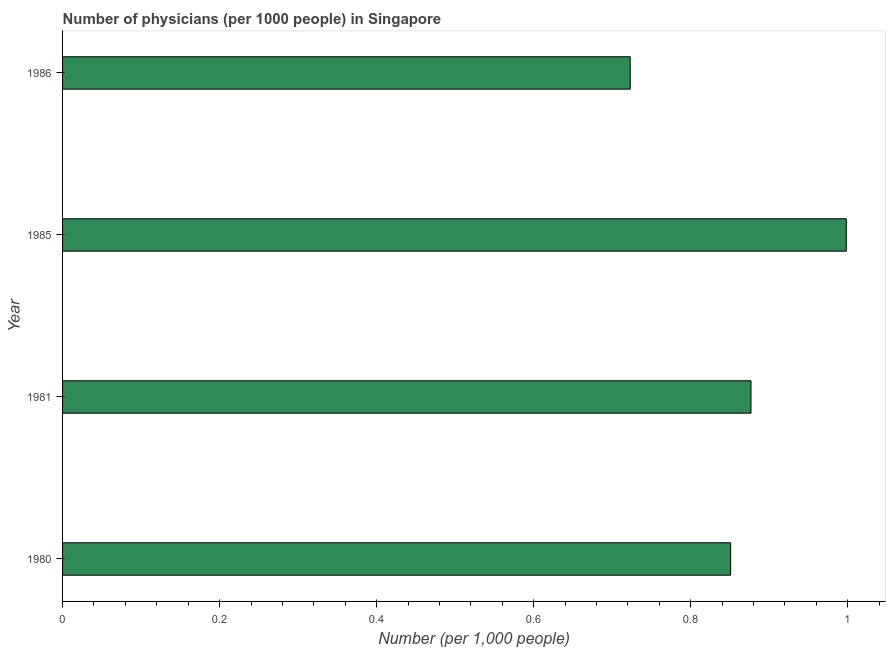Does the graph contain any zero values?
Make the answer very short. No. Does the graph contain grids?
Your answer should be very brief. No. What is the title of the graph?
Offer a terse response. Number of physicians (per 1000 people) in Singapore. What is the label or title of the X-axis?
Your response must be concise. Number (per 1,0 people). What is the label or title of the Y-axis?
Offer a very short reply. Year. What is the number of physicians in 1985?
Offer a very short reply. 1. Across all years, what is the maximum number of physicians?
Your answer should be compact. 1. Across all years, what is the minimum number of physicians?
Provide a succinct answer. 0.72. In which year was the number of physicians minimum?
Ensure brevity in your answer.  1986. What is the sum of the number of physicians?
Your answer should be compact. 3.45. What is the difference between the number of physicians in 1980 and 1986?
Your answer should be very brief. 0.13. What is the average number of physicians per year?
Ensure brevity in your answer.  0.86. What is the median number of physicians?
Give a very brief answer. 0.86. Do a majority of the years between 1985 and 1981 (inclusive) have number of physicians greater than 0.72 ?
Your answer should be compact. No. What is the ratio of the number of physicians in 1981 to that in 1986?
Provide a short and direct response. 1.21. Is the number of physicians in 1980 less than that in 1981?
Keep it short and to the point. Yes. What is the difference between the highest and the second highest number of physicians?
Provide a short and direct response. 0.12. Is the sum of the number of physicians in 1980 and 1986 greater than the maximum number of physicians across all years?
Offer a terse response. Yes. What is the difference between the highest and the lowest number of physicians?
Keep it short and to the point. 0.28. Are all the bars in the graph horizontal?
Your answer should be very brief. Yes. What is the Number (per 1,000 people) in 1980?
Keep it short and to the point. 0.85. What is the Number (per 1,000 people) of 1981?
Make the answer very short. 0.88. What is the Number (per 1,000 people) of 1985?
Offer a terse response. 1. What is the Number (per 1,000 people) of 1986?
Your response must be concise. 0.72. What is the difference between the Number (per 1,000 people) in 1980 and 1981?
Keep it short and to the point. -0.03. What is the difference between the Number (per 1,000 people) in 1980 and 1985?
Your response must be concise. -0.15. What is the difference between the Number (per 1,000 people) in 1980 and 1986?
Offer a very short reply. 0.13. What is the difference between the Number (per 1,000 people) in 1981 and 1985?
Ensure brevity in your answer.  -0.12. What is the difference between the Number (per 1,000 people) in 1981 and 1986?
Make the answer very short. 0.15. What is the difference between the Number (per 1,000 people) in 1985 and 1986?
Give a very brief answer. 0.28. What is the ratio of the Number (per 1,000 people) in 1980 to that in 1981?
Your response must be concise. 0.97. What is the ratio of the Number (per 1,000 people) in 1980 to that in 1985?
Make the answer very short. 0.85. What is the ratio of the Number (per 1,000 people) in 1980 to that in 1986?
Provide a succinct answer. 1.18. What is the ratio of the Number (per 1,000 people) in 1981 to that in 1985?
Make the answer very short. 0.88. What is the ratio of the Number (per 1,000 people) in 1981 to that in 1986?
Make the answer very short. 1.21. What is the ratio of the Number (per 1,000 people) in 1985 to that in 1986?
Give a very brief answer. 1.38. 